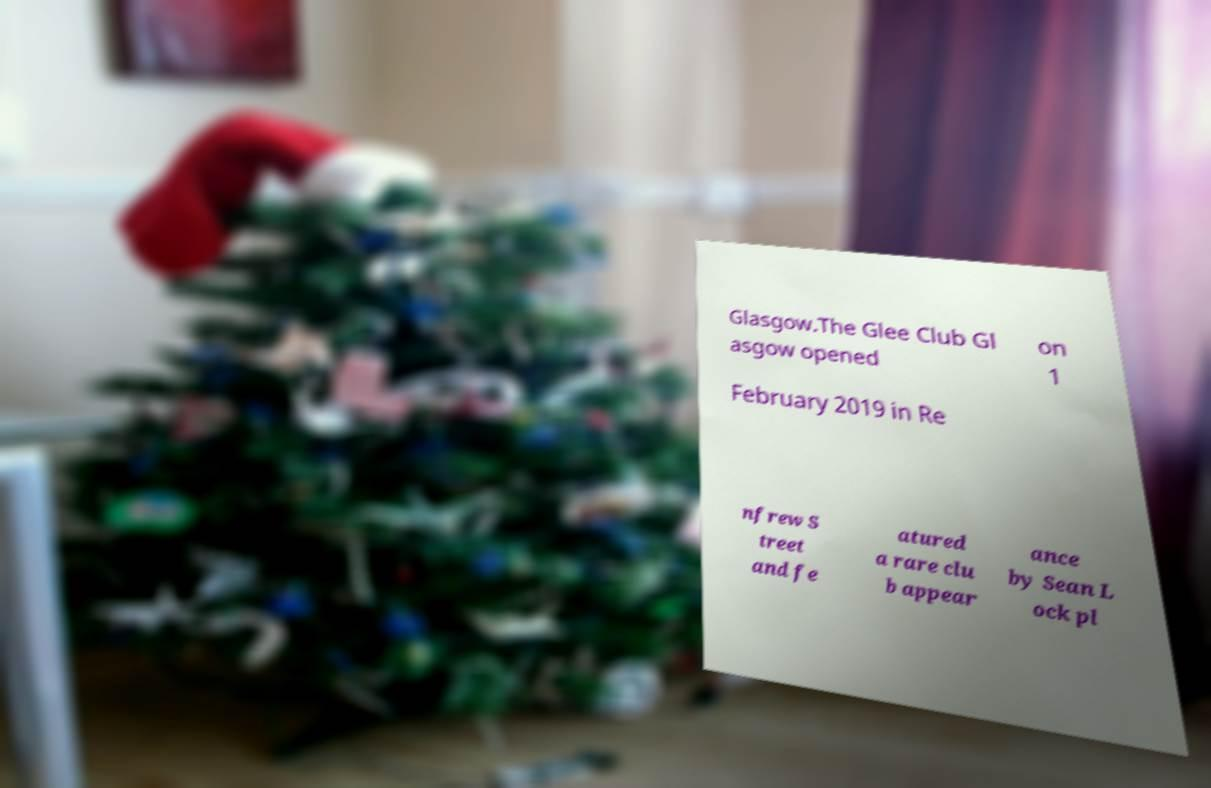Could you extract and type out the text from this image? Glasgow.The Glee Club Gl asgow opened on 1 February 2019 in Re nfrew S treet and fe atured a rare clu b appear ance by Sean L ock pl 